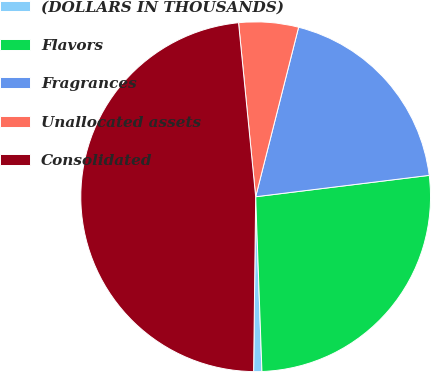Convert chart to OTSL. <chart><loc_0><loc_0><loc_500><loc_500><pie_chart><fcel>(DOLLARS IN THOUSANDS)<fcel>Flavors<fcel>Fragrances<fcel>Unallocated assets<fcel>Consolidated<nl><fcel>0.76%<fcel>26.38%<fcel>19.1%<fcel>5.51%<fcel>48.25%<nl></chart> 